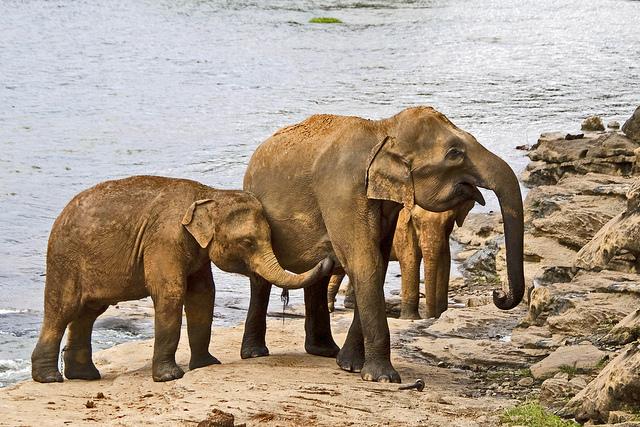How many elephants are there?
Answer briefly. 3. Is the small elephant touching the big elephant with his trunk?
Give a very brief answer. Yes. Could this be on a river?
Answer briefly. Yes. 